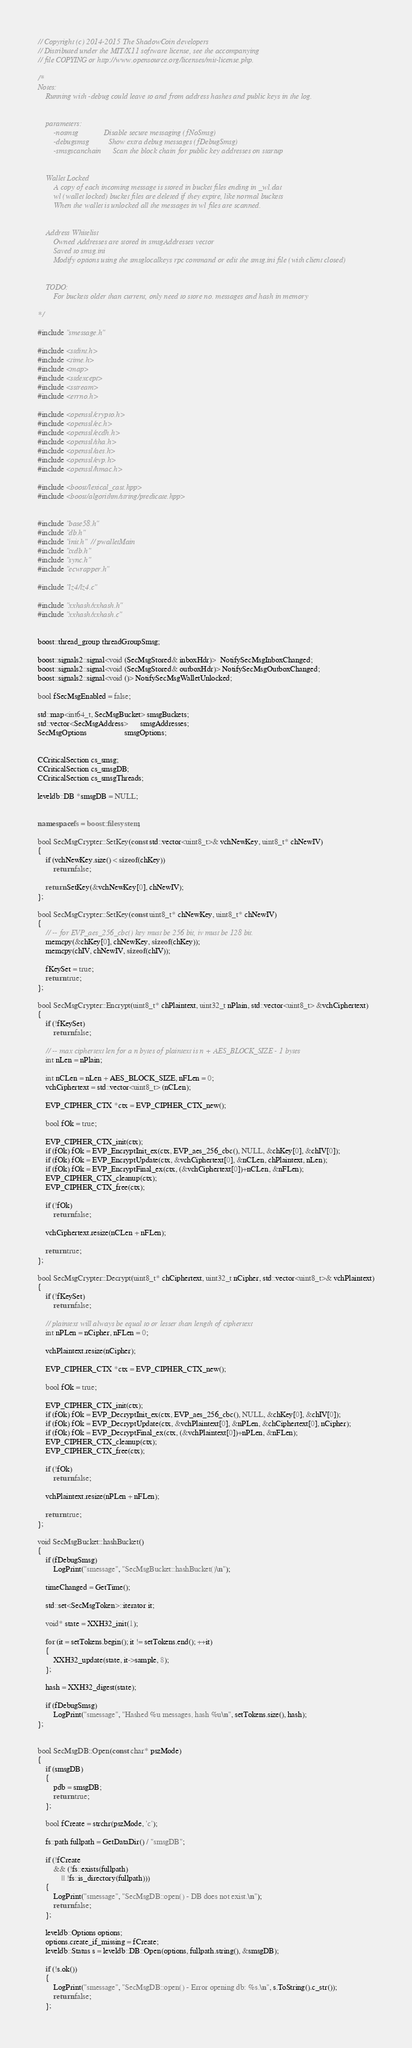<code> <loc_0><loc_0><loc_500><loc_500><_C++_>// Copyright (c) 2014-2015 The ShadowCoin developers
// Distributed under the MIT/X11 software license, see the accompanying
// file COPYING or http://www.opensource.org/licenses/mit-license.php.

/*
Notes:
    Running with -debug could leave to and from address hashes and public keys in the log.


    parameters:
        -nosmsg             Disable secure messaging (fNoSmsg)
        -debugsmsg          Show extra debug messages (fDebugSmsg)
        -smsgscanchain      Scan the block chain for public key addresses on startup


    Wallet Locked
        A copy of each incoming message is stored in bucket files ending in _wl.dat
        wl (wallet locked) bucket files are deleted if they expire, like normal buckets
        When the wallet is unlocked all the messages in wl files are scanned.


    Address Whitelist
        Owned Addresses are stored in smsgAddresses vector
        Saved to smsg.ini
        Modify options using the smsglocalkeys rpc command or edit the smsg.ini file (with client closed)
    
    
    TODO:
        For buckets older than current, only need to store no. messages and hash in memory

*/

#include "smessage.h"

#include <stdint.h>
#include <time.h>
#include <map>
#include <stdexcept>
#include <sstream>
#include <errno.h>

#include <openssl/crypto.h>
#include <openssl/ec.h>
#include <openssl/ecdh.h>
#include <openssl/sha.h>
#include <openssl/aes.h>
#include <openssl/evp.h>
#include <openssl/hmac.h>

#include <boost/lexical_cast.hpp>
#include <boost/algorithm/string/predicate.hpp>


#include "base58.h"
#include "db.h"
#include "init.h" // pwalletMain
#include "txdb.h"
#include "sync.h"
#include "ecwrapper.h"

#include "lz4/lz4.c"

#include "xxhash/xxhash.h"
#include "xxhash/xxhash.c"


boost::thread_group threadGroupSmsg;

boost::signals2::signal<void (SecMsgStored& inboxHdr)>  NotifySecMsgInboxChanged;
boost::signals2::signal<void (SecMsgStored& outboxHdr)> NotifySecMsgOutboxChanged;
boost::signals2::signal<void ()> NotifySecMsgWalletUnlocked;

bool fSecMsgEnabled = false;

std::map<int64_t, SecMsgBucket> smsgBuckets;
std::vector<SecMsgAddress>      smsgAddresses;
SecMsgOptions                   smsgOptions;


CCriticalSection cs_smsg;
CCriticalSection cs_smsgDB;
CCriticalSection cs_smsgThreads;

leveldb::DB *smsgDB = NULL;


namespace fs = boost::filesystem;

bool SecMsgCrypter::SetKey(const std::vector<uint8_t>& vchNewKey, uint8_t* chNewIV)
{
    if (vchNewKey.size() < sizeof(chKey))
        return false;

    return SetKey(&vchNewKey[0], chNewIV);
};

bool SecMsgCrypter::SetKey(const uint8_t* chNewKey, uint8_t* chNewIV)
{
    // -- for EVP_aes_256_cbc() key must be 256 bit, iv must be 128 bit.
    memcpy(&chKey[0], chNewKey, sizeof(chKey));
    memcpy(chIV, chNewIV, sizeof(chIV));

    fKeySet = true;
    return true;
};

bool SecMsgCrypter::Encrypt(uint8_t* chPlaintext, uint32_t nPlain, std::vector<uint8_t> &vchCiphertext)
{
    if (!fKeySet)
        return false;

    // -- max ciphertext len for a n bytes of plaintext is n + AES_BLOCK_SIZE - 1 bytes
    int nLen = nPlain;

    int nCLen = nLen + AES_BLOCK_SIZE, nFLen = 0;
    vchCiphertext = std::vector<uint8_t> (nCLen);

    EVP_CIPHER_CTX *ctx = EVP_CIPHER_CTX_new();

    bool fOk = true;

    EVP_CIPHER_CTX_init(ctx);
    if (fOk) fOk = EVP_EncryptInit_ex(ctx, EVP_aes_256_cbc(), NULL, &chKey[0], &chIV[0]);
    if (fOk) fOk = EVP_EncryptUpdate(ctx, &vchCiphertext[0], &nCLen, chPlaintext, nLen);
    if (fOk) fOk = EVP_EncryptFinal_ex(ctx, (&vchCiphertext[0])+nCLen, &nFLen);
    EVP_CIPHER_CTX_cleanup(ctx);
    EVP_CIPHER_CTX_free(ctx);

    if (!fOk)
        return false;

    vchCiphertext.resize(nCLen + nFLen);

    return true;
};

bool SecMsgCrypter::Decrypt(uint8_t* chCiphertext, uint32_t nCipher, std::vector<uint8_t>& vchPlaintext)
{
    if (!fKeySet)
        return false;

    // plaintext will always be equal to or lesser than length of ciphertext
    int nPLen = nCipher, nFLen = 0;

    vchPlaintext.resize(nCipher);

    EVP_CIPHER_CTX *ctx = EVP_CIPHER_CTX_new();

    bool fOk = true;

    EVP_CIPHER_CTX_init(ctx);
    if (fOk) fOk = EVP_DecryptInit_ex(ctx, EVP_aes_256_cbc(), NULL, &chKey[0], &chIV[0]);
    if (fOk) fOk = EVP_DecryptUpdate(ctx, &vchPlaintext[0], &nPLen, &chCiphertext[0], nCipher);
    if (fOk) fOk = EVP_DecryptFinal_ex(ctx, (&vchPlaintext[0])+nPLen, &nFLen);
    EVP_CIPHER_CTX_cleanup(ctx);
    EVP_CIPHER_CTX_free(ctx);

    if (!fOk)
        return false;

    vchPlaintext.resize(nPLen + nFLen);

    return true;
};

void SecMsgBucket::hashBucket()
{
    if (fDebugSmsg)
        LogPrint("smessage", "SecMsgBucket::hashBucket()\n");
    
    timeChanged = GetTime();
    
    std::set<SecMsgToken>::iterator it;
    
    void* state = XXH32_init(1);
    
    for (it = setTokens.begin(); it != setTokens.end(); ++it)
    {
        XXH32_update(state, it->sample, 8);
    };
    
    hash = XXH32_digest(state);
    
    if (fDebugSmsg)
        LogPrint("smessage", "Hashed %u messages, hash %u\n", setTokens.size(), hash);
};


bool SecMsgDB::Open(const char* pszMode)
{
    if (smsgDB)
    {
        pdb = smsgDB;
        return true;
    };

    bool fCreate = strchr(pszMode, 'c');

    fs::path fullpath = GetDataDir() / "smsgDB";

    if (!fCreate
        && (!fs::exists(fullpath)
            || !fs::is_directory(fullpath)))
    {
        LogPrint("smessage", "SecMsgDB::open() - DB does not exist.\n");
        return false;
    };

    leveldb::Options options;
    options.create_if_missing = fCreate;
    leveldb::Status s = leveldb::DB::Open(options, fullpath.string(), &smsgDB);

    if (!s.ok())
    {
        LogPrint("smessage", "SecMsgDB::open() - Error opening db: %s.\n", s.ToString().c_str());
        return false;
    };
</code> 